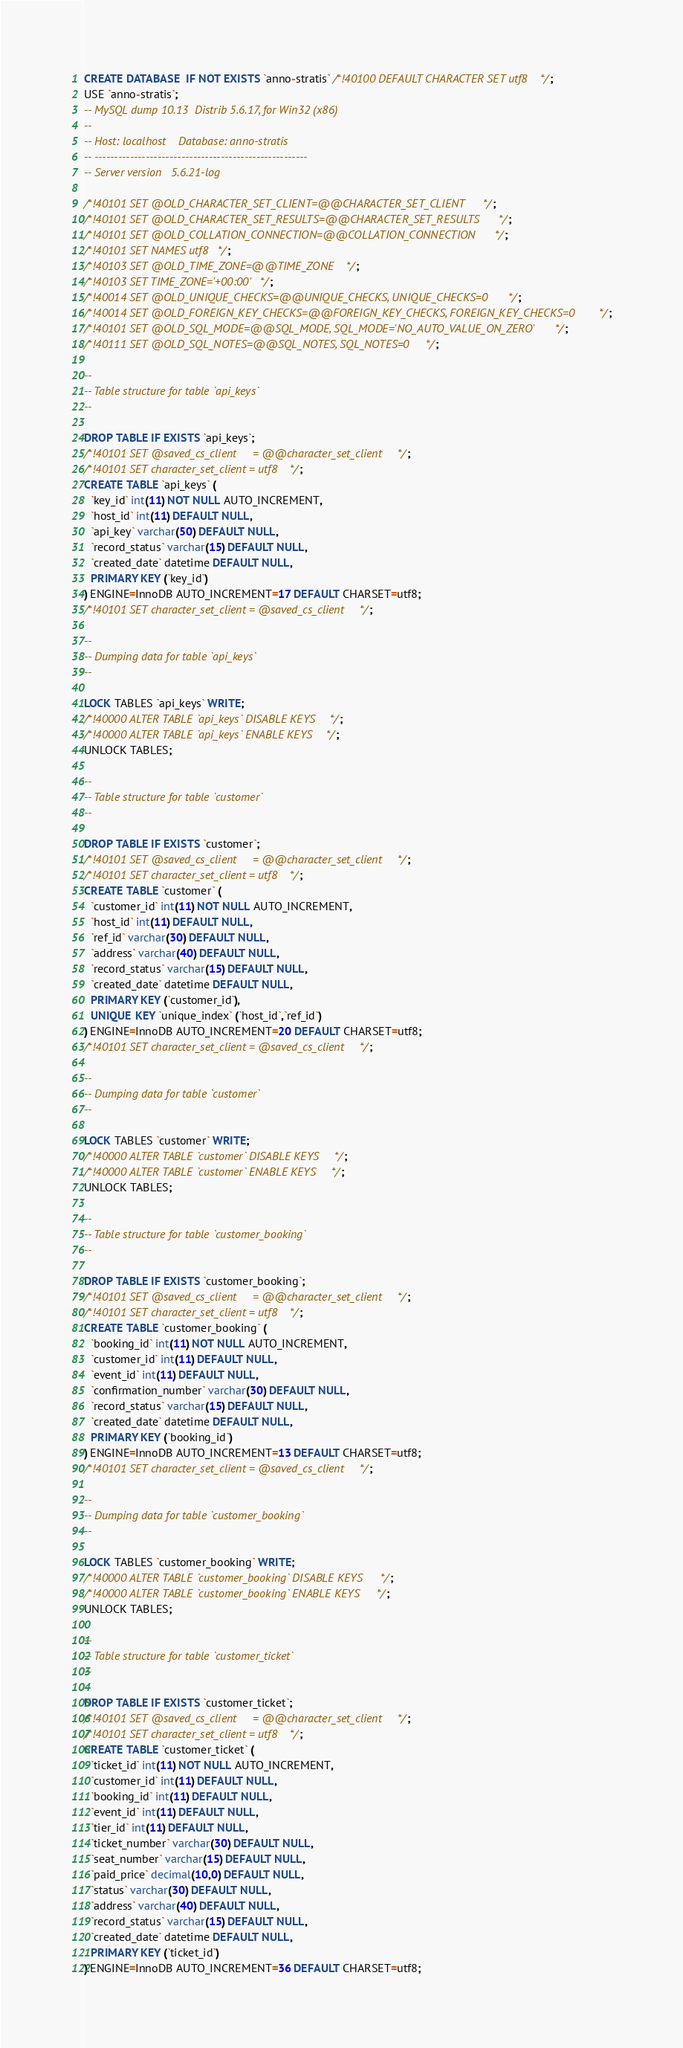<code> <loc_0><loc_0><loc_500><loc_500><_SQL_>CREATE DATABASE  IF NOT EXISTS `anno-stratis` /*!40100 DEFAULT CHARACTER SET utf8 */;
USE `anno-stratis`;
-- MySQL dump 10.13  Distrib 5.6.17, for Win32 (x86)
--
-- Host: localhost    Database: anno-stratis
-- ------------------------------------------------------
-- Server version	5.6.21-log

/*!40101 SET @OLD_CHARACTER_SET_CLIENT=@@CHARACTER_SET_CLIENT */;
/*!40101 SET @OLD_CHARACTER_SET_RESULTS=@@CHARACTER_SET_RESULTS */;
/*!40101 SET @OLD_COLLATION_CONNECTION=@@COLLATION_CONNECTION */;
/*!40101 SET NAMES utf8 */;
/*!40103 SET @OLD_TIME_ZONE=@@TIME_ZONE */;
/*!40103 SET TIME_ZONE='+00:00' */;
/*!40014 SET @OLD_UNIQUE_CHECKS=@@UNIQUE_CHECKS, UNIQUE_CHECKS=0 */;
/*!40014 SET @OLD_FOREIGN_KEY_CHECKS=@@FOREIGN_KEY_CHECKS, FOREIGN_KEY_CHECKS=0 */;
/*!40101 SET @OLD_SQL_MODE=@@SQL_MODE, SQL_MODE='NO_AUTO_VALUE_ON_ZERO' */;
/*!40111 SET @OLD_SQL_NOTES=@@SQL_NOTES, SQL_NOTES=0 */;

--
-- Table structure for table `api_keys`
--

DROP TABLE IF EXISTS `api_keys`;
/*!40101 SET @saved_cs_client     = @@character_set_client */;
/*!40101 SET character_set_client = utf8 */;
CREATE TABLE `api_keys` (
  `key_id` int(11) NOT NULL AUTO_INCREMENT,
  `host_id` int(11) DEFAULT NULL,
  `api_key` varchar(50) DEFAULT NULL,
  `record_status` varchar(15) DEFAULT NULL,
  `created_date` datetime DEFAULT NULL,
  PRIMARY KEY (`key_id`)
) ENGINE=InnoDB AUTO_INCREMENT=17 DEFAULT CHARSET=utf8;
/*!40101 SET character_set_client = @saved_cs_client */;

--
-- Dumping data for table `api_keys`
--

LOCK TABLES `api_keys` WRITE;
/*!40000 ALTER TABLE `api_keys` DISABLE KEYS */;
/*!40000 ALTER TABLE `api_keys` ENABLE KEYS */;
UNLOCK TABLES;

--
-- Table structure for table `customer`
--

DROP TABLE IF EXISTS `customer`;
/*!40101 SET @saved_cs_client     = @@character_set_client */;
/*!40101 SET character_set_client = utf8 */;
CREATE TABLE `customer` (
  `customer_id` int(11) NOT NULL AUTO_INCREMENT,
  `host_id` int(11) DEFAULT NULL,
  `ref_id` varchar(30) DEFAULT NULL,
  `address` varchar(40) DEFAULT NULL,
  `record_status` varchar(15) DEFAULT NULL,
  `created_date` datetime DEFAULT NULL,
  PRIMARY KEY (`customer_id`),
  UNIQUE KEY `unique_index` (`host_id`,`ref_id`)
) ENGINE=InnoDB AUTO_INCREMENT=20 DEFAULT CHARSET=utf8;
/*!40101 SET character_set_client = @saved_cs_client */;

--
-- Dumping data for table `customer`
--

LOCK TABLES `customer` WRITE;
/*!40000 ALTER TABLE `customer` DISABLE KEYS */;
/*!40000 ALTER TABLE `customer` ENABLE KEYS */;
UNLOCK TABLES;

--
-- Table structure for table `customer_booking`
--

DROP TABLE IF EXISTS `customer_booking`;
/*!40101 SET @saved_cs_client     = @@character_set_client */;
/*!40101 SET character_set_client = utf8 */;
CREATE TABLE `customer_booking` (
  `booking_id` int(11) NOT NULL AUTO_INCREMENT,
  `customer_id` int(11) DEFAULT NULL,
  `event_id` int(11) DEFAULT NULL,
  `confirmation_number` varchar(30) DEFAULT NULL,
  `record_status` varchar(15) DEFAULT NULL,
  `created_date` datetime DEFAULT NULL,
  PRIMARY KEY (`booking_id`)
) ENGINE=InnoDB AUTO_INCREMENT=13 DEFAULT CHARSET=utf8;
/*!40101 SET character_set_client = @saved_cs_client */;

--
-- Dumping data for table `customer_booking`
--

LOCK TABLES `customer_booking` WRITE;
/*!40000 ALTER TABLE `customer_booking` DISABLE KEYS */;
/*!40000 ALTER TABLE `customer_booking` ENABLE KEYS */;
UNLOCK TABLES;

--
-- Table structure for table `customer_ticket`
--

DROP TABLE IF EXISTS `customer_ticket`;
/*!40101 SET @saved_cs_client     = @@character_set_client */;
/*!40101 SET character_set_client = utf8 */;
CREATE TABLE `customer_ticket` (
  `ticket_id` int(11) NOT NULL AUTO_INCREMENT,
  `customer_id` int(11) DEFAULT NULL,
  `booking_id` int(11) DEFAULT NULL,
  `event_id` int(11) DEFAULT NULL,
  `tier_id` int(11) DEFAULT NULL,
  `ticket_number` varchar(30) DEFAULT NULL,
  `seat_number` varchar(15) DEFAULT NULL,
  `paid_price` decimal(10,0) DEFAULT NULL,
  `status` varchar(30) DEFAULT NULL,
  `address` varchar(40) DEFAULT NULL,
  `record_status` varchar(15) DEFAULT NULL,
  `created_date` datetime DEFAULT NULL,
  PRIMARY KEY (`ticket_id`)
) ENGINE=InnoDB AUTO_INCREMENT=36 DEFAULT CHARSET=utf8;</code> 